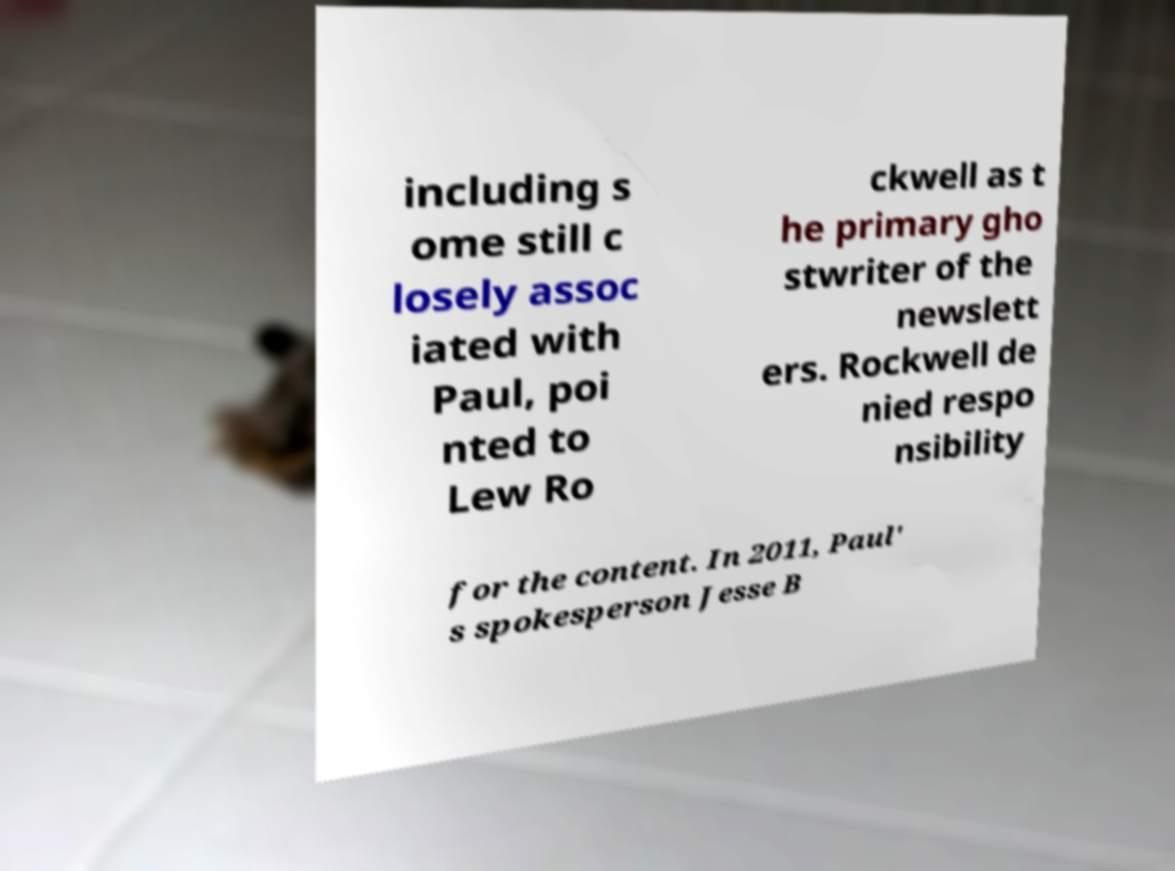Can you read and provide the text displayed in the image?This photo seems to have some interesting text. Can you extract and type it out for me? including s ome still c losely assoc iated with Paul, poi nted to Lew Ro ckwell as t he primary gho stwriter of the newslett ers. Rockwell de nied respo nsibility for the content. In 2011, Paul' s spokesperson Jesse B 